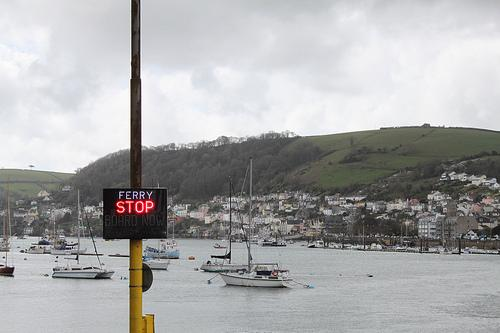Describe the various water bodies present in the image along with their characteristics. There is a large sea with calm water, a body of calm water, and a body of water that is calm, all present in the image. Briefly describe the scene in the harbor. The scene in the harbor includes boats at anchor and docked, hills rising up from the harbor, and low hanging clouds during daytime. What type of animals are present in the image, and how many of them are there? There are 5 ducks swimming at different positions in the image. What is the most prominent natural feature in this scene? A giant green hill is the most prominent natural feature in the scene. List down the colors and types of clouds in the image. There are grey clouds and white clouds in the image. What color are the clouds near the top of the image? Grey How many houses are there in the group of large houses, and what color are they? There are multiple large houses, and they are white. Based on the image, describe the activity happening around the white sailboats. The white sailboats are anchored in the harbor with ducks swimming nearby, and hills as the backdrop. What species of bird can be seen swimming in the image?  Ducks Do you see any ducks flying in the sky? While there are multiple ducks in the image, none of them are described as flying. All of the ducks mentioned are "swimming," and their positions are on or near the water, not in the sky. What is the dominant feature in the background of the image? A giant green hill Describe the expression of the people in the image. There are no people in the image. What is happening in the harbor at daytime with low hanging clouds? Boats are moored, and there are ducks swimming in the water, a pier, and green hills in the background. Can you find a large group of purple houses near the center of the image? No, it's not mentioned in the image. Create a caption for the image with a focus on the atmosphere. Serene harbor scene with boats, green hills, and clouds setting a calming atmosphere. Identify and describe any birds present in the image. There are ducks swimming in the water. Where is the electric ferry stop sign located on the image? It is placed near the yellow pole. Choose the most fitting caption for the image: (A) Boats in a desert, (B) City skyline, or (C) Serene harbor scene with boats and hills. (C) Serene harbor scene with boats and hills. What is the purpose of the tall white object near the sailboat in the image? It is the mast of a sailboat. Identify the buildings that can be seen in the image. A group of large houses. Are there any grey clouds located to the right of the image? There are grey clouds mentioned, but their position is not to the right of the image. The grey clouds are described as being located at X:216 Y:8 Width:91 Height:91, which would put them more towards the top left area of the image. Is there a red sailboat near the top left corner of the image? There is actually a red sailboat mentioned in the objects' list, but it is not near the top left corner - the coordinates are X:2 and Y:187, which is more towards the bottom left corner of the image. Make an event description based on the image provided. A daytime harbor event with boats, a pier, and low hanging clouds prevails. Interpret the scene with the water, boats, and surrounding area. A peaceful harbor scene with boats at anchor and dock, calm water, and picturesque hills. Using the provided data, describe the presence and activity of the ducks in the harbor. There are several ducks of varying sizes swimming in the calm waters of the harbor. Create a multi-modal piece of content based on the image. Aesthetic harbor painting with descriptive text: "Soothing harbor getaway - escape the city life and immerse yourself in tranquility." Are there any red sailboats in the image? If so, describe their appearance. Yes, there is a red sailboat in the image, which is small in size. In the image, what kind of sign is lit up by the yellow pole? An electric ferry stop sign with the word "stop" lit up in red. Is there a giant, orange hill in the image? There is a hill in the image, but it is not described as orange, it is described as a giant green hill - "a giant green hill X:347 Y:120 Width:87 Height:87". 